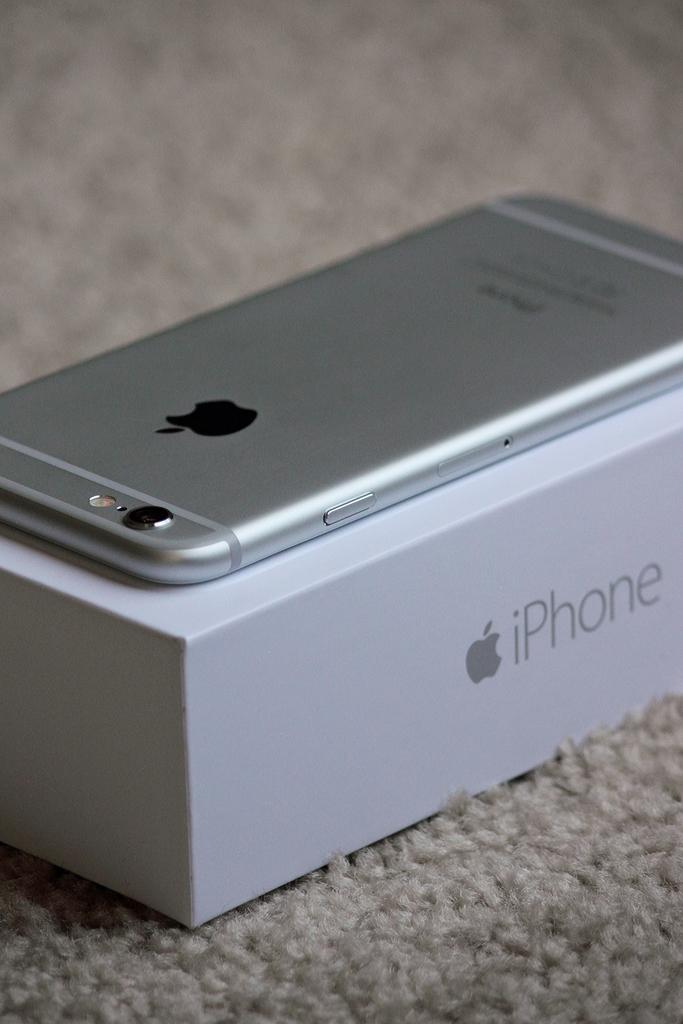What kind of phone is this?
Provide a short and direct response. Iphone. 